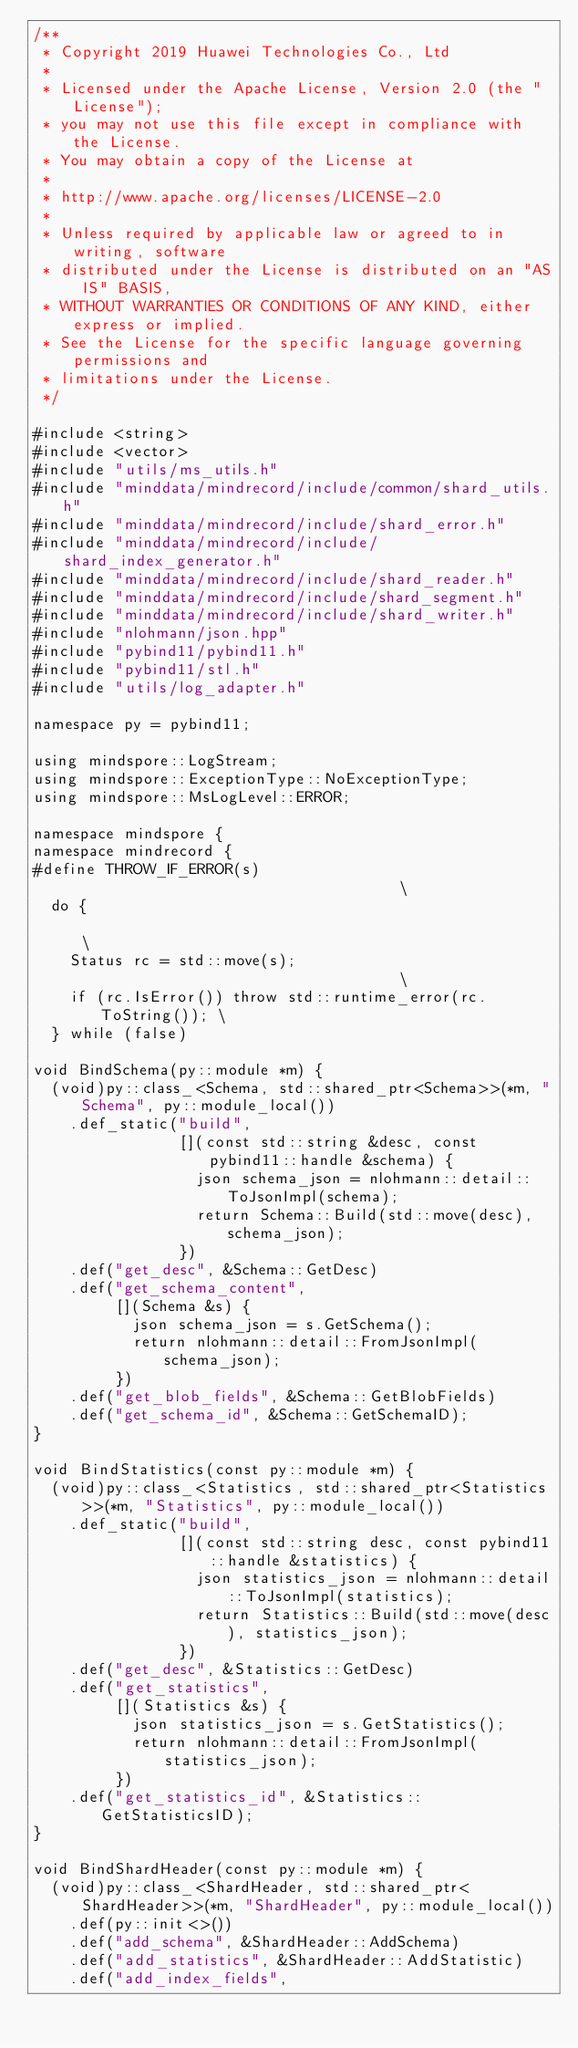Convert code to text. <code><loc_0><loc_0><loc_500><loc_500><_C++_>/**
 * Copyright 2019 Huawei Technologies Co., Ltd
 *
 * Licensed under the Apache License, Version 2.0 (the "License");
 * you may not use this file except in compliance with the License.
 * You may obtain a copy of the License at
 *
 * http://www.apache.org/licenses/LICENSE-2.0
 *
 * Unless required by applicable law or agreed to in writing, software
 * distributed under the License is distributed on an "AS IS" BASIS,
 * WITHOUT WARRANTIES OR CONDITIONS OF ANY KIND, either express or implied.
 * See the License for the specific language governing permissions and
 * limitations under the License.
 */

#include <string>
#include <vector>
#include "utils/ms_utils.h"
#include "minddata/mindrecord/include/common/shard_utils.h"
#include "minddata/mindrecord/include/shard_error.h"
#include "minddata/mindrecord/include/shard_index_generator.h"
#include "minddata/mindrecord/include/shard_reader.h"
#include "minddata/mindrecord/include/shard_segment.h"
#include "minddata/mindrecord/include/shard_writer.h"
#include "nlohmann/json.hpp"
#include "pybind11/pybind11.h"
#include "pybind11/stl.h"
#include "utils/log_adapter.h"

namespace py = pybind11;

using mindspore::LogStream;
using mindspore::ExceptionType::NoExceptionType;
using mindspore::MsLogLevel::ERROR;

namespace mindspore {
namespace mindrecord {
#define THROW_IF_ERROR(s)                                      \
  do {                                                         \
    Status rc = std::move(s);                                  \
    if (rc.IsError()) throw std::runtime_error(rc.ToString()); \
  } while (false)

void BindSchema(py::module *m) {
  (void)py::class_<Schema, std::shared_ptr<Schema>>(*m, "Schema", py::module_local())
    .def_static("build",
                [](const std::string &desc, const pybind11::handle &schema) {
                  json schema_json = nlohmann::detail::ToJsonImpl(schema);
                  return Schema::Build(std::move(desc), schema_json);
                })
    .def("get_desc", &Schema::GetDesc)
    .def("get_schema_content",
         [](Schema &s) {
           json schema_json = s.GetSchema();
           return nlohmann::detail::FromJsonImpl(schema_json);
         })
    .def("get_blob_fields", &Schema::GetBlobFields)
    .def("get_schema_id", &Schema::GetSchemaID);
}

void BindStatistics(const py::module *m) {
  (void)py::class_<Statistics, std::shared_ptr<Statistics>>(*m, "Statistics", py::module_local())
    .def_static("build",
                [](const std::string desc, const pybind11::handle &statistics) {
                  json statistics_json = nlohmann::detail::ToJsonImpl(statistics);
                  return Statistics::Build(std::move(desc), statistics_json);
                })
    .def("get_desc", &Statistics::GetDesc)
    .def("get_statistics",
         [](Statistics &s) {
           json statistics_json = s.GetStatistics();
           return nlohmann::detail::FromJsonImpl(statistics_json);
         })
    .def("get_statistics_id", &Statistics::GetStatisticsID);
}

void BindShardHeader(const py::module *m) {
  (void)py::class_<ShardHeader, std::shared_ptr<ShardHeader>>(*m, "ShardHeader", py::module_local())
    .def(py::init<>())
    .def("add_schema", &ShardHeader::AddSchema)
    .def("add_statistics", &ShardHeader::AddStatistic)
    .def("add_index_fields",</code> 